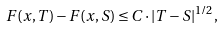<formula> <loc_0><loc_0><loc_500><loc_500>F ( x , T ) - F ( x , S ) \leq C \cdot | T - S | ^ { 1 / 2 } ,</formula> 